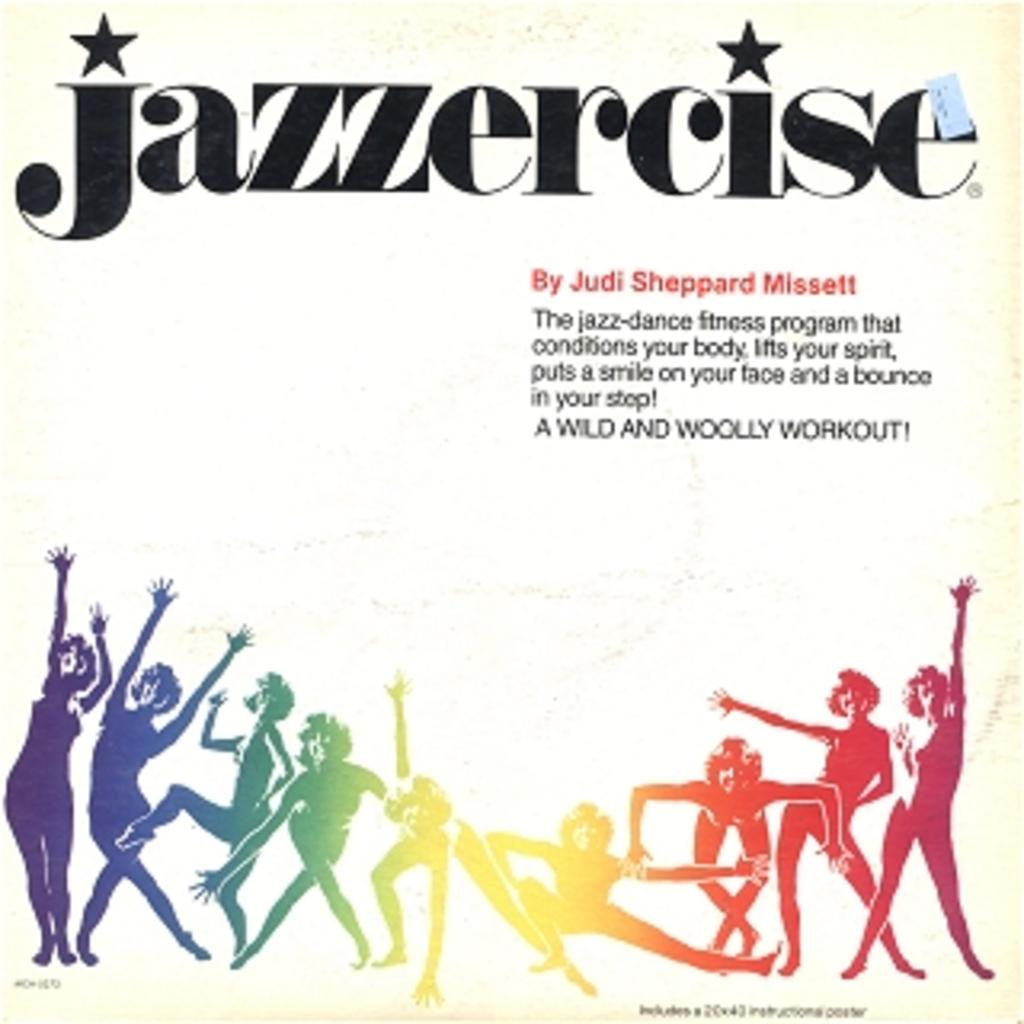What type of image is being described? The image is a poster. What can be seen on the poster? There are persons depicted on the poster. Are there any words or phrases on the poster? Yes, there is text present on the poster. What type of prison can be seen in the background of the poster? There is no prison present in the image; it is a poster featuring persons and text. What material is the beggar's hat made of in the image? There is no beggar present in the image, and therefore no hat to describe. 